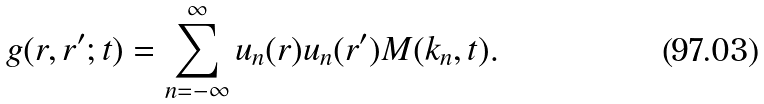Convert formula to latex. <formula><loc_0><loc_0><loc_500><loc_500>g ( r , r ^ { \prime } ; t ) = \sum _ { n = - \infty } ^ { \infty } u _ { n } ( r ) u _ { n } ( r ^ { \prime } ) M ( k _ { n } , t ) .</formula> 